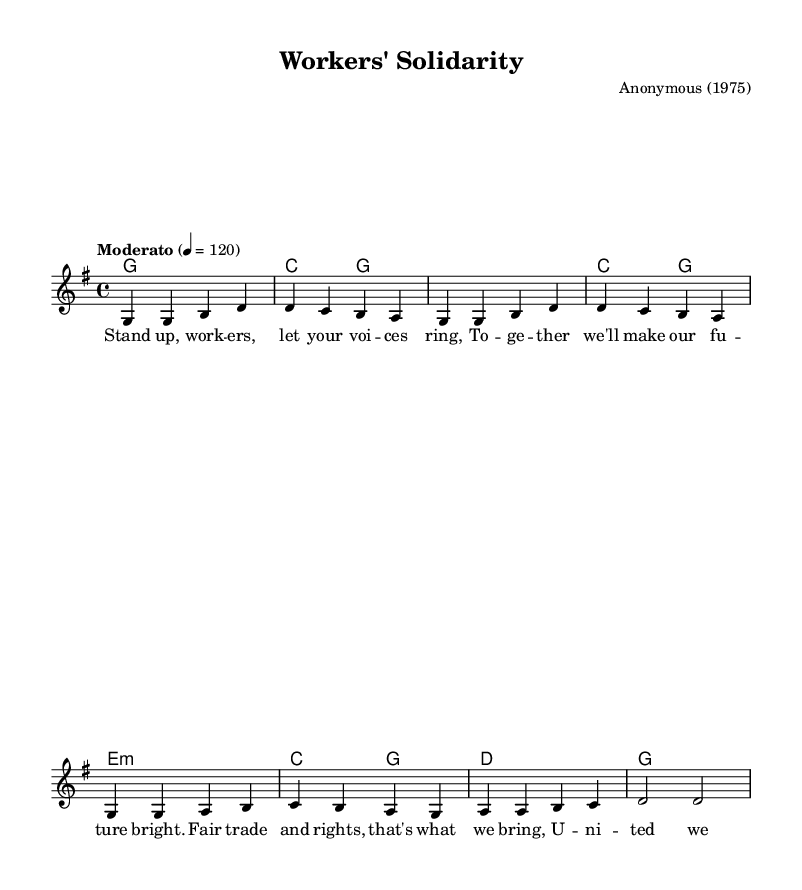What is the key signature of this music? The key signature is G major, which has one sharp (F#) and is indicated at the beginning of the staff.
Answer: G major What is the time signature? The time signature is 4/4, as indicated at the beginning of the piece, meaning there are four beats in a measure and the quarter note receives one beat.
Answer: 4/4 What is the tempo marking given in the music? The tempo marking is "Moderato," which typically refers to a moderate speed of the music. Additionally, the specific tempo is set at 120 beats per minute, shown by the '4 = 120' indication.
Answer: Moderato How many measures are in the piece? By counting the measures shown in the melody and harmonies, we find there are 8 measures present in total.
Answer: 8 What is the title of the song? The title of the song is "Workers' Solidarity," indicated at the top of the music sheet under the header section.
Answer: Workers' Solidarity What year was this piece composed? The year of composition is indicated as 1975 in the header section of the sheet music.
Answer: 1975 What is the main lyrical theme of the song? The main theme revolves around workers' rights and solidarity, emphasizing unity and the fight for fair trade practices. This can be gleaned from the content of the lyrics provided alongside the melody.
Answer: Workers' rights 